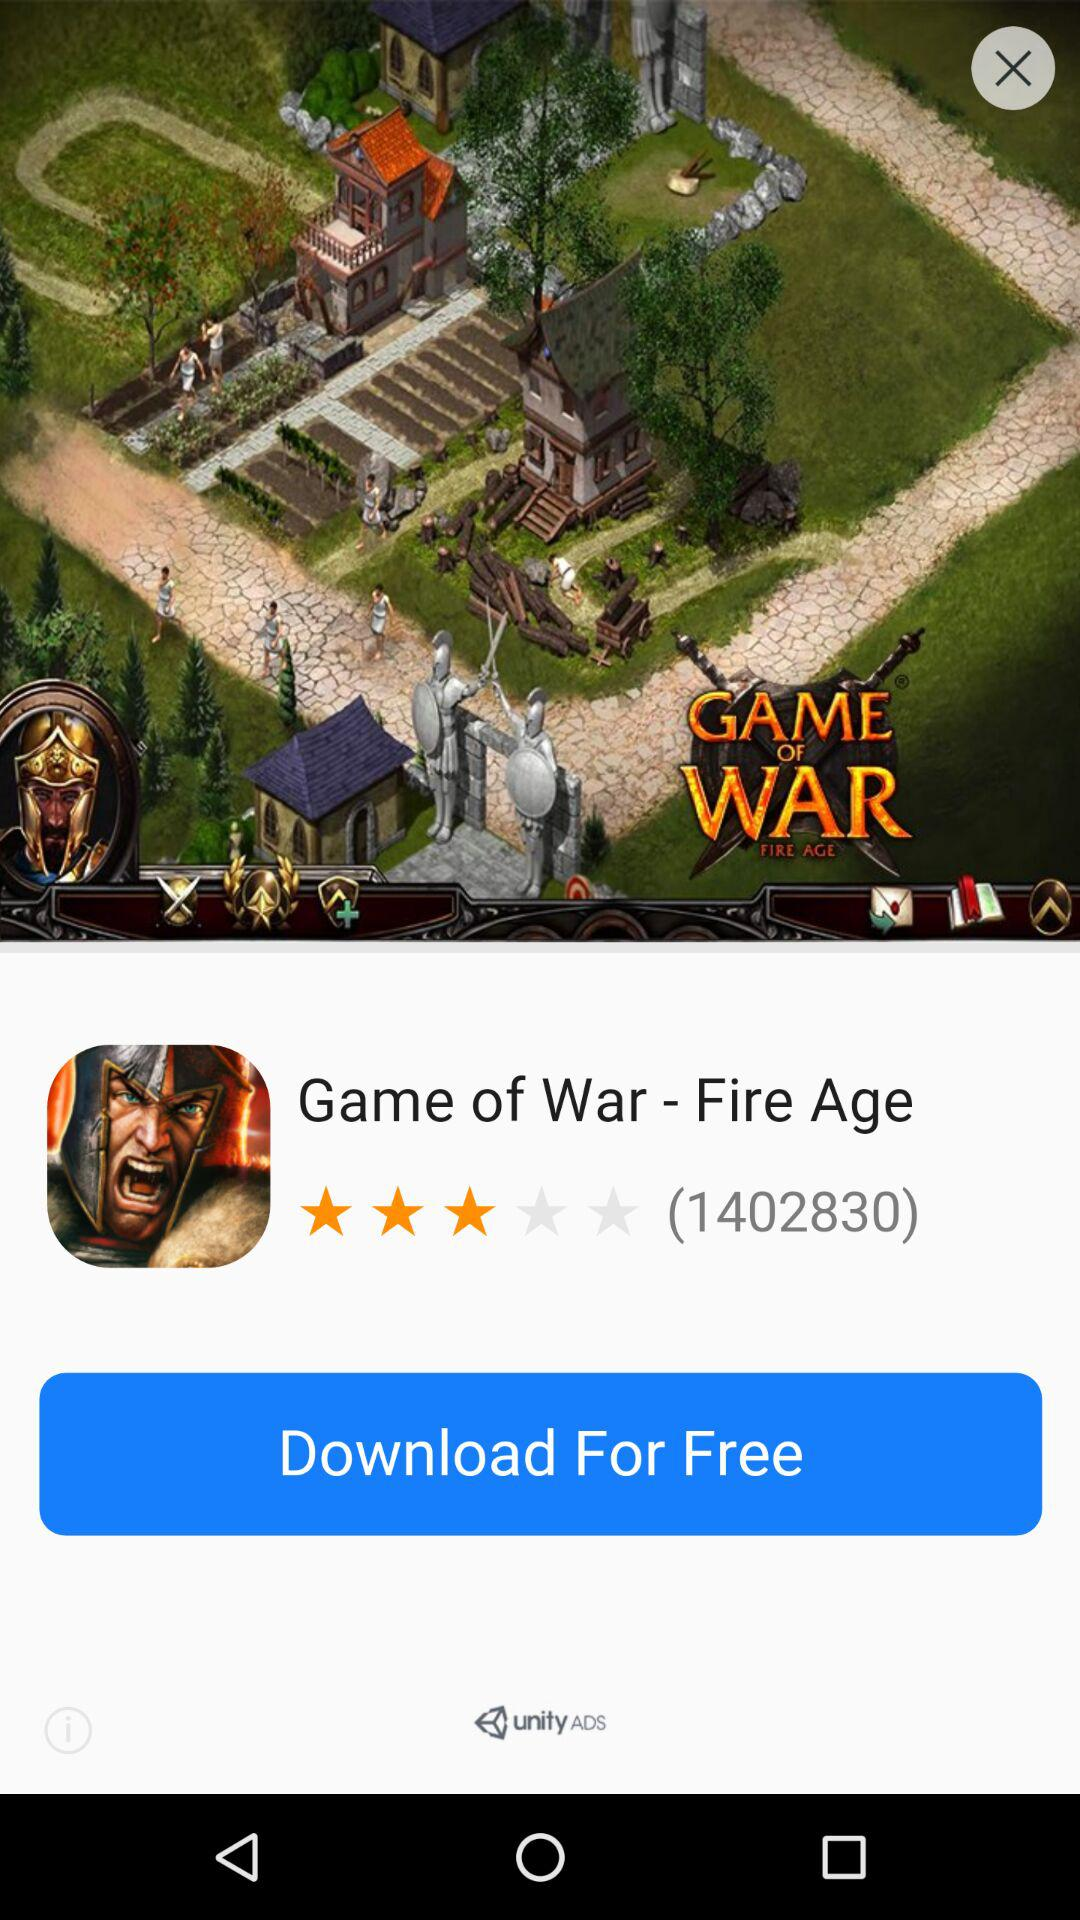Is downloading free or paid?
Answer the question using a single word or phrase. Downloading is free. 